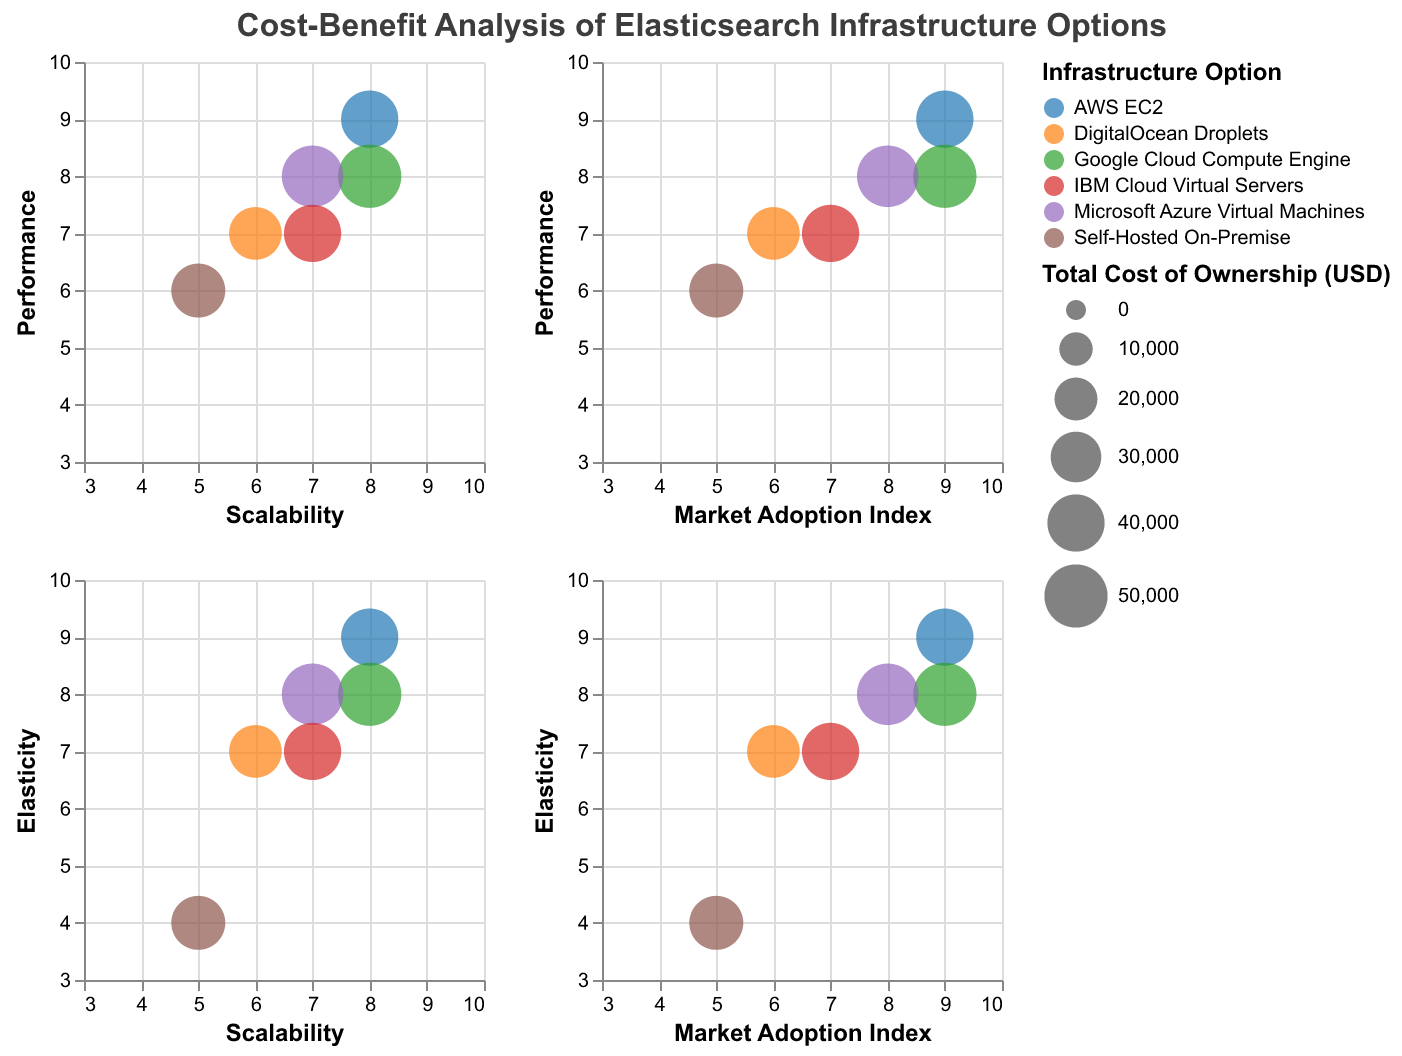What is the title of the figure? The title of the figure is usually displayed at the top of the chart. In this case, it is clearly indicated in the `title` section of the data.
Answer: Cost-Benefit Analysis of Elasticsearch Infrastructure Options Which infrastructure option has the highest initial setup cost? Look for the infrastructure option with the highest value in the "Initial Setup Cost (USD)" field from the data. Google Cloud Compute Engine has the highest initial setup cost of $12,000.
Answer: Google Cloud Compute Engine Which infrastructure option has the lowest total cost of ownership? Compare the "Total Cost of Ownership (USD)" values across all infrastructure options. DigitalOcean Droplets has the lowest total cost of ownership of $33,000.
Answer: DigitalOcean Droplets What are the x and y-axis labels in the chart corresponding to the "Performance" vs "Scalability" subplot? The x and y labels can be inferred from the repeat rows and columns specified in the data configuration. For "Performance" vs "Scalability", the x-axis is "Scalability", and the y-axis is "Performance".
Answer: Scalability, Performance How many infrastructure options have a total cost of ownership of $40,000? Count the number of entries in the data where "Total Cost of Ownership (USD)" is $40,000. AWS EC2 and IBM Cloud Virtual Servers both have a total cost of ownership of $40,000.
Answer: 2 Which infrastructure option has the highest performance rating? Look for the infrastructure option with the highest value in the "Performance" field. AWS EC2 has the highest performance rating of 9.
Answer: AWS EC2 Which infrastructure option scores the lowest in elasticity? Compare the "Elasticity" values for all infrastructure options. Self-Hosted On-Premise scores the lowest in elasticity with a value of 4.
Answer: Self-Hosted On-Premise How does the performance of Google Cloud Compute Engine compare to Microsoft Azure Virtual Machines? Compare the "Performance" values for both options. Google Cloud Compute Engine has a performance rating of 8, whereas Microsoft Azure Virtual Machines has a performance rating of 8. Both have the same performance score.
Answer: They have the same performance score Which infrastructure option has a lower initial setup cost but higher total cost of ownership compared to Self-Hosted On-Premise? Check for options with a lower initial setup cost than $5000 but higher total cost of ownership than $35000. There is no such infrastructure option that matches both criteria.
Answer: None What is the range of values for the "Market Adoption Index" in the chart? Identify the smallest and largest values of "Market Adoption Index". The values range from 5 to 9.
Answer: 5 to 9 